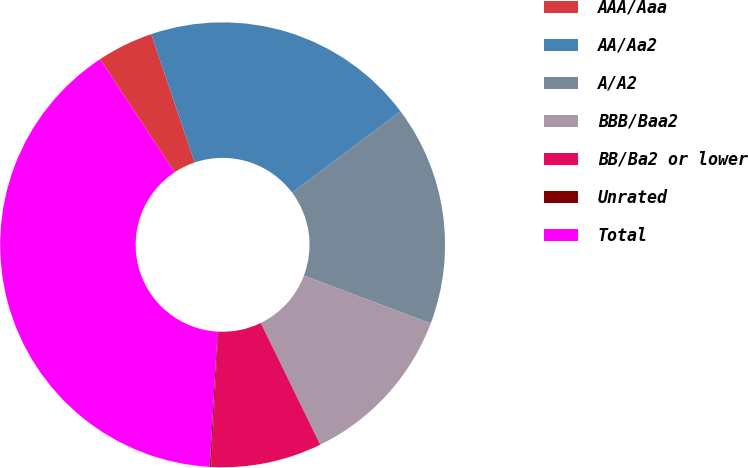Convert chart to OTSL. <chart><loc_0><loc_0><loc_500><loc_500><pie_chart><fcel>AAA/Aaa<fcel>AA/Aa2<fcel>A/A2<fcel>BBB/Baa2<fcel>BB/Ba2 or lower<fcel>Unrated<fcel>Total<nl><fcel>4.08%<fcel>19.96%<fcel>15.99%<fcel>12.02%<fcel>8.05%<fcel>0.1%<fcel>39.81%<nl></chart> 